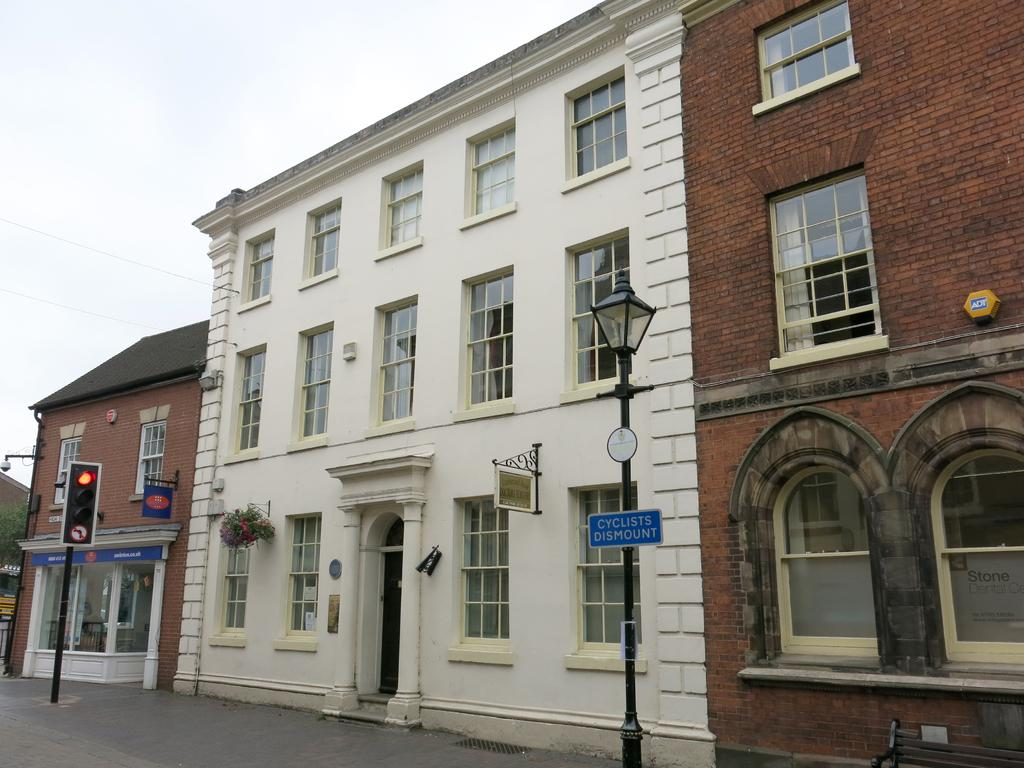What is located at the bottom of the image? There is a road at the bottom of the image. What can be seen in the center of the image? There are buildings with windows and doors in the center of the image. What objects are present in the image that are not buildings or the road? There are poles in the image. What is visible at the top of the image? The sky is visible at the top of the image. Can you see any veins in the image? There are no veins present in the image. Are there any faces visible in the image? There are no faces visible in the image. 